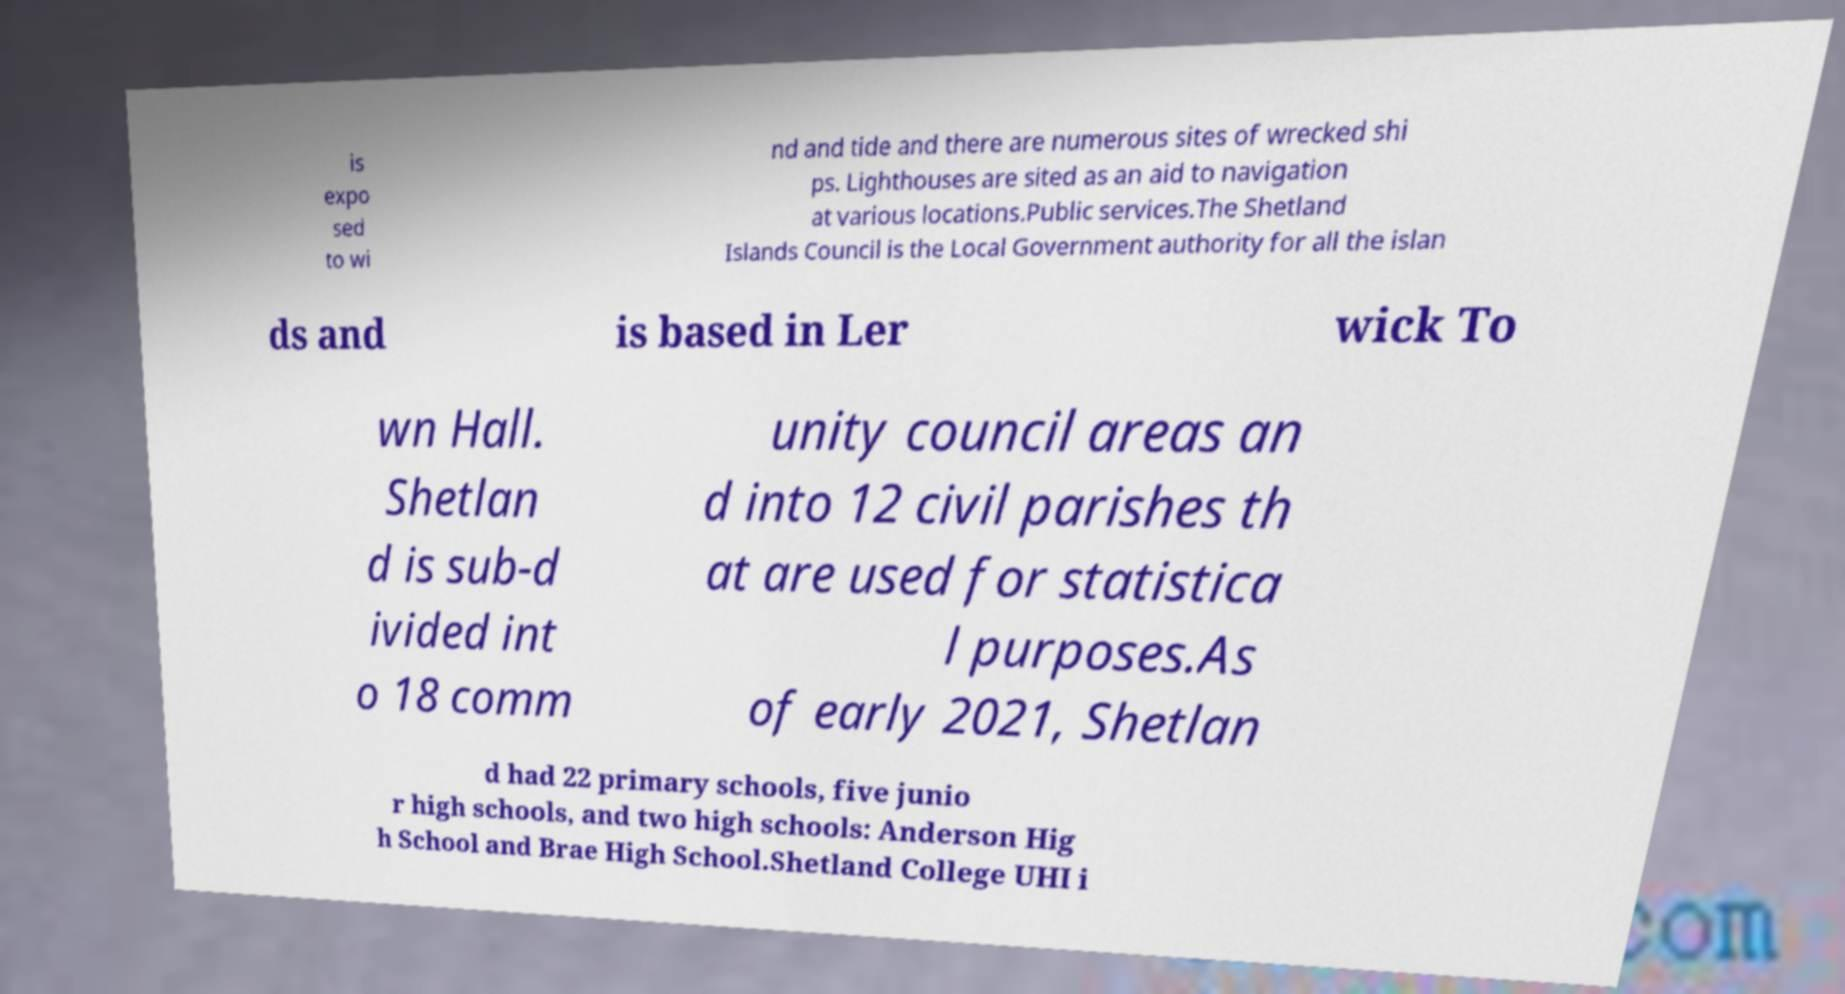Can you accurately transcribe the text from the provided image for me? is expo sed to wi nd and tide and there are numerous sites of wrecked shi ps. Lighthouses are sited as an aid to navigation at various locations.Public services.The Shetland Islands Council is the Local Government authority for all the islan ds and is based in Ler wick To wn Hall. Shetlan d is sub-d ivided int o 18 comm unity council areas an d into 12 civil parishes th at are used for statistica l purposes.As of early 2021, Shetlan d had 22 primary schools, five junio r high schools, and two high schools: Anderson Hig h School and Brae High School.Shetland College UHI i 